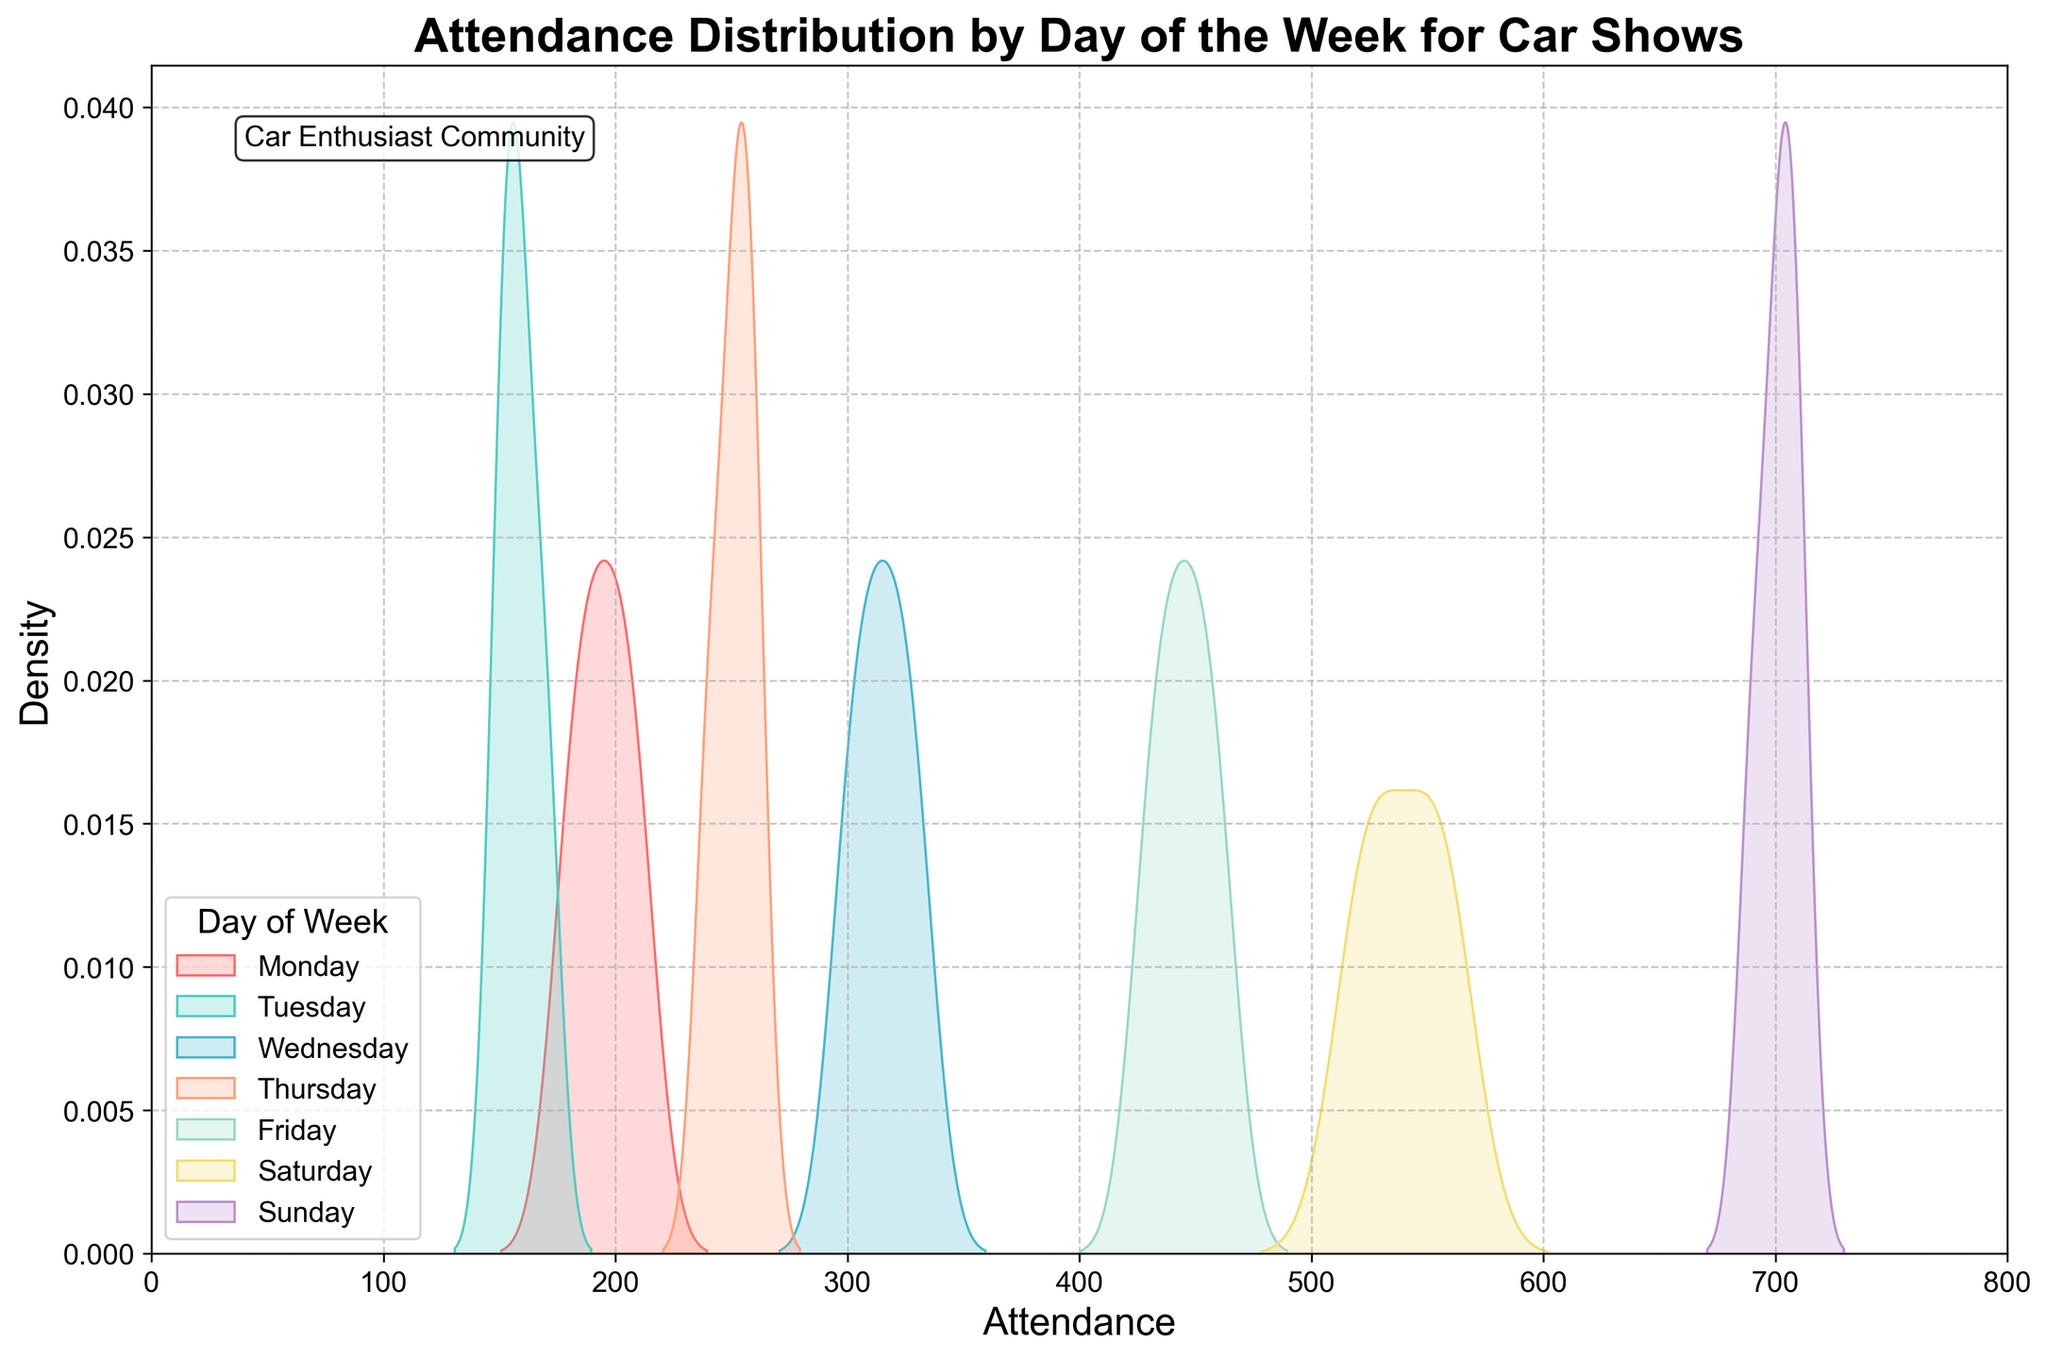What is the title of the plot? The title of the plot is located at the top of the figure and is typically formatted in a larger, bold font. It provides a summary of what the figure is about. Here it reads "Attendance Distribution by Day of the Week for Car Shows".
Answer: Attendance Distribution by Day of the Week for Car Shows What is shown on the x-axis of the plot? The x-axis typically represents the variable that is being measured. In this case, the label on the x-axis shows "Attendance", indicating that it represents the number of attendees at the car shows.
Answer: Attendance Which day of the week appears to have the highest peak in attendance density? By observing the peaks of the density curves, the day with the highest peak can be identified. The curve for Sunday reaches the highest peak compared to other days.
Answer: Sunday Comparing Monday and Friday, which has a higher average attendance? The peaks of the density plots indicate the most common values. The plot for Friday peaks higher on the attendance scale than Monday’s plot, suggesting a higher average attendance on Friday.
Answer: Friday How does the attendance on Saturday generally compare to Thursday? By comparing the peaks and the spread of the density plots for both days, it can be observed that Saturday has a higher peak and a wider spread towards higher attendance numbers than Thursday.
Answer: Higher Which day has the most variability in attendance? Variability can be assessed by the width of the density curves. Wider curves suggest more variability. The curve for Saturday appears wider than other days, indicating higher variability.
Answer: Saturday What is the x-axis limit set in the plot? Observing the range of the x-axis, where the attendance is plotted, it starts from 0 and ends at 800. This range is set by the limits of the x-axis.
Answer: 0 to 800 Do any of the days have overlapping attendance ranges? If so, which ones? Observing the curves, the attendance ranges for some days overlap. Notably, the attendance distributions for Thursday and Friday have overlapping ranges and so do Monday and Tuesday.
Answer: Thursday and Friday, Monday and Tuesday What specific color represents Tuesday's attendance distribution? The colors for each day are distinct and set as per a predefined palette. The second color listed is designated for Tuesday, which, looking at the figure, is a greenish shade.
Answer: Greenish shade 